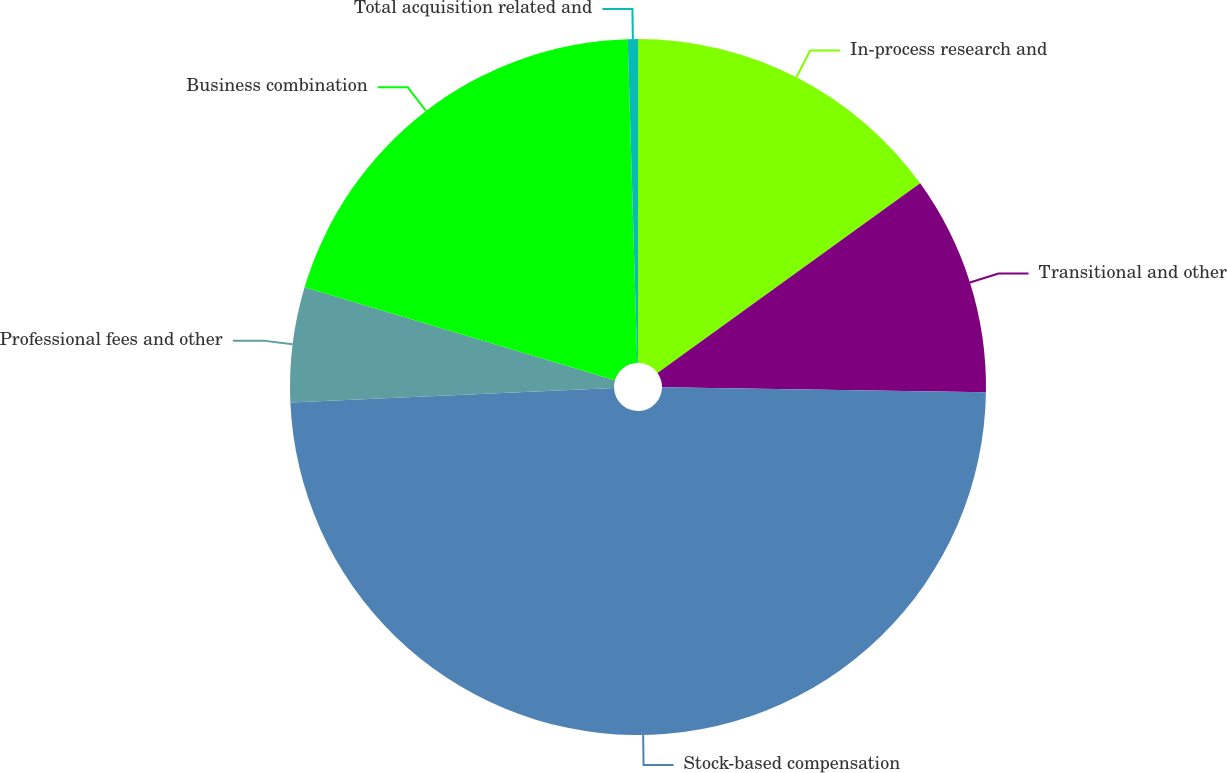Convert chart to OTSL. <chart><loc_0><loc_0><loc_500><loc_500><pie_chart><fcel>In-process research and<fcel>Transitional and other<fcel>Stock-based compensation<fcel>Professional fees and other<fcel>Business combination<fcel>Total acquisition related and<nl><fcel>15.05%<fcel>10.19%<fcel>49.06%<fcel>5.33%<fcel>19.91%<fcel>0.47%<nl></chart> 